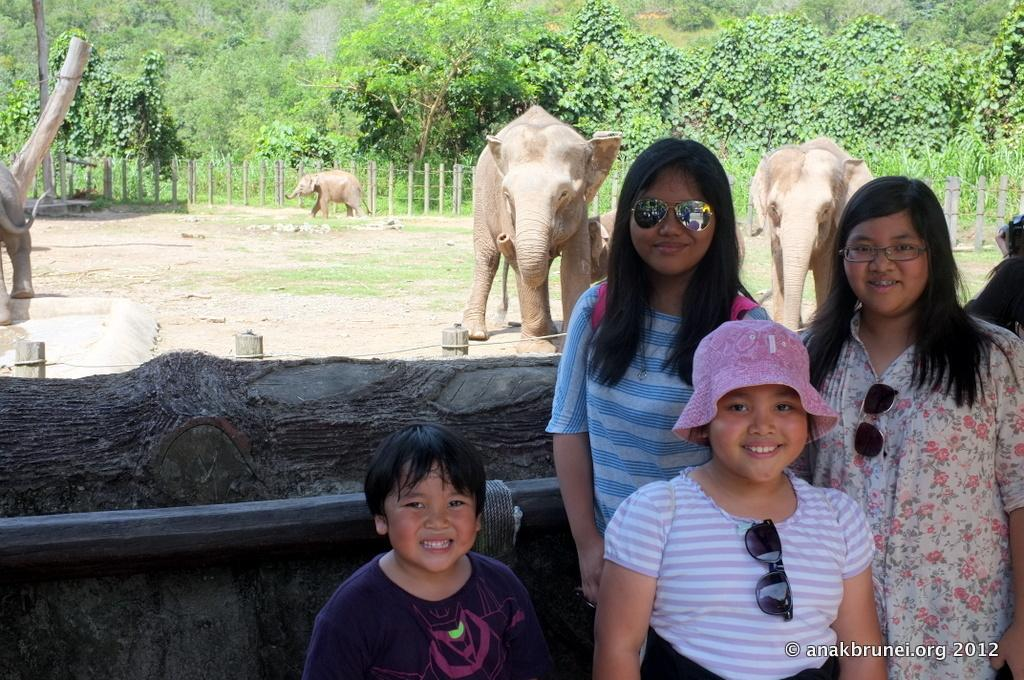What are the people in the image doing? The people in the image are standing on the ground and smiling. What can be seen in the background of the image? In the background of the image, there are elephants, trees, a fence, plants, and other objects. Can you describe the people's expressions in the image? The people in the image are smiling. What type of flag is being waved by the creator of the image? There is no flag or creator mentioned in the image, so it is not possible to answer that question. 